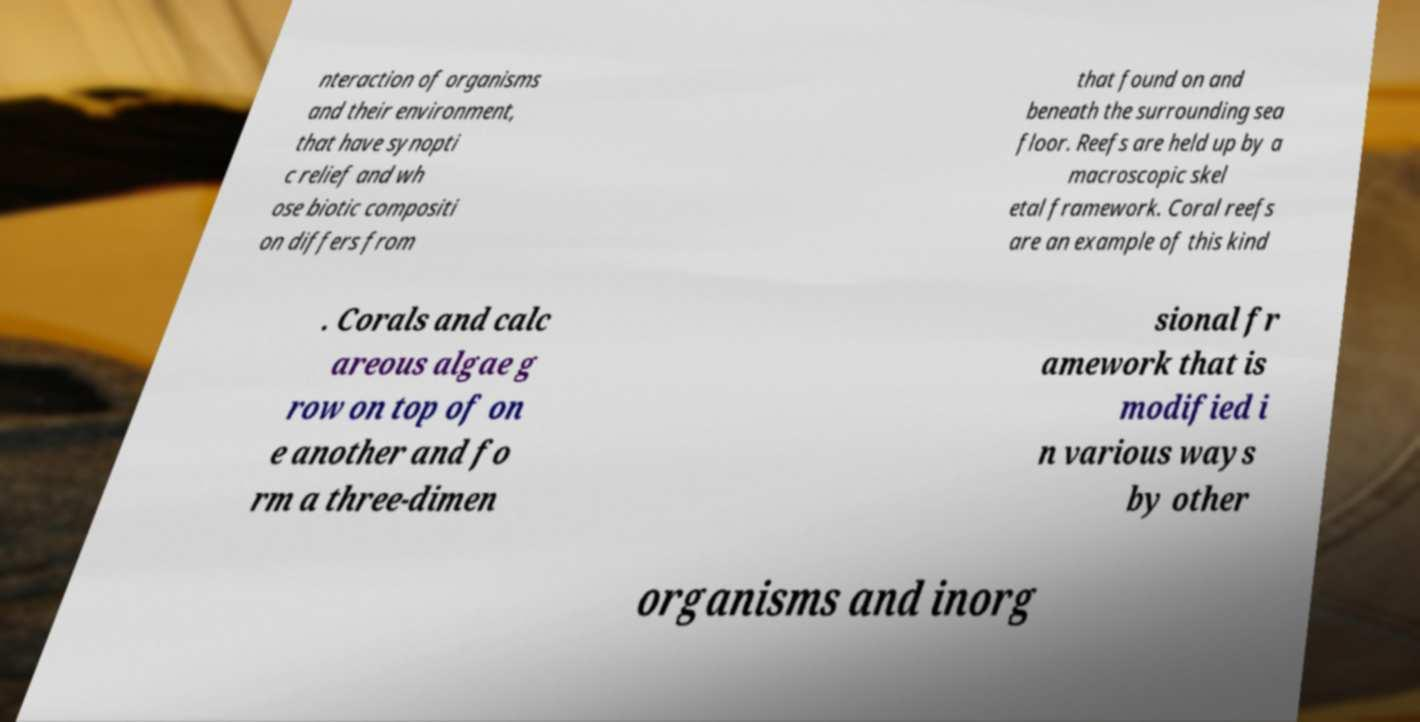Can you read and provide the text displayed in the image?This photo seems to have some interesting text. Can you extract and type it out for me? nteraction of organisms and their environment, that have synopti c relief and wh ose biotic compositi on differs from that found on and beneath the surrounding sea floor. Reefs are held up by a macroscopic skel etal framework. Coral reefs are an example of this kind . Corals and calc areous algae g row on top of on e another and fo rm a three-dimen sional fr amework that is modified i n various ways by other organisms and inorg 